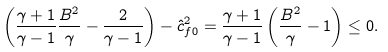Convert formula to latex. <formula><loc_0><loc_0><loc_500><loc_500>\left ( \frac { \gamma + 1 } { \gamma - 1 } \frac { B ^ { 2 } } { \gamma } - \frac { 2 } { \gamma - 1 } \right ) - \hat { c } _ { f 0 } ^ { 2 } = \frac { \gamma + 1 } { \gamma - 1 } \left ( \frac { B ^ { 2 } } { \gamma } - 1 \right ) \leq 0 .</formula> 